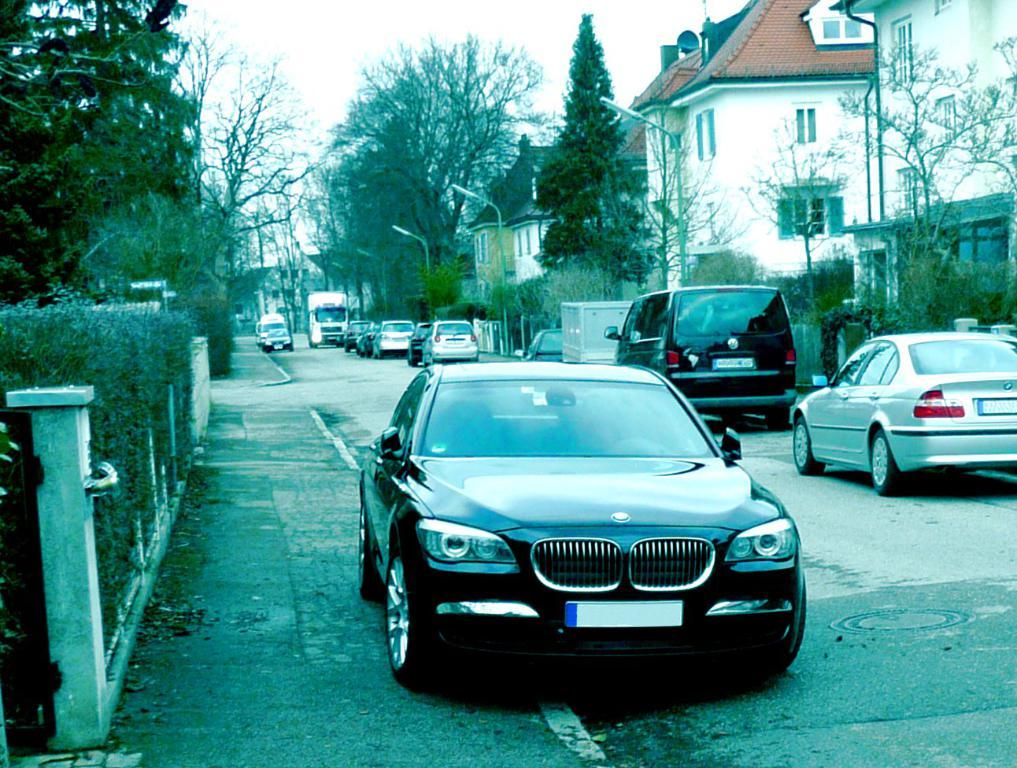What type of structures can be seen in the image? There are buildings in the image. What is happening in front of the buildings? There are vehicles on the road in front of the buildings. What type of lighting is present in the image? There are street lights in the image. What type of vegetation is visible in the image? There are trees in the image. What can be seen above the buildings and trees? The sky is visible in the image. How many teeth can be seen on the buildings in the image? There are no teeth present on the buildings in the image; teeth are a characteristic of living organisms, not structures. 